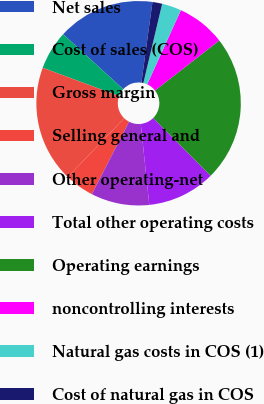Convert chart. <chart><loc_0><loc_0><loc_500><loc_500><pie_chart><fcel>Net sales<fcel>Cost of sales (COS)<fcel>Gross margin<fcel>Selling general and<fcel>Other operating-net<fcel>Total other operating costs<fcel>Operating earnings<fcel>noncontrolling interests<fcel>Natural gas costs in COS (1)<fcel>Cost of natural gas in COS<nl><fcel>15.38%<fcel>6.15%<fcel>18.46%<fcel>4.62%<fcel>9.23%<fcel>10.77%<fcel>23.07%<fcel>7.69%<fcel>3.08%<fcel>1.54%<nl></chart> 